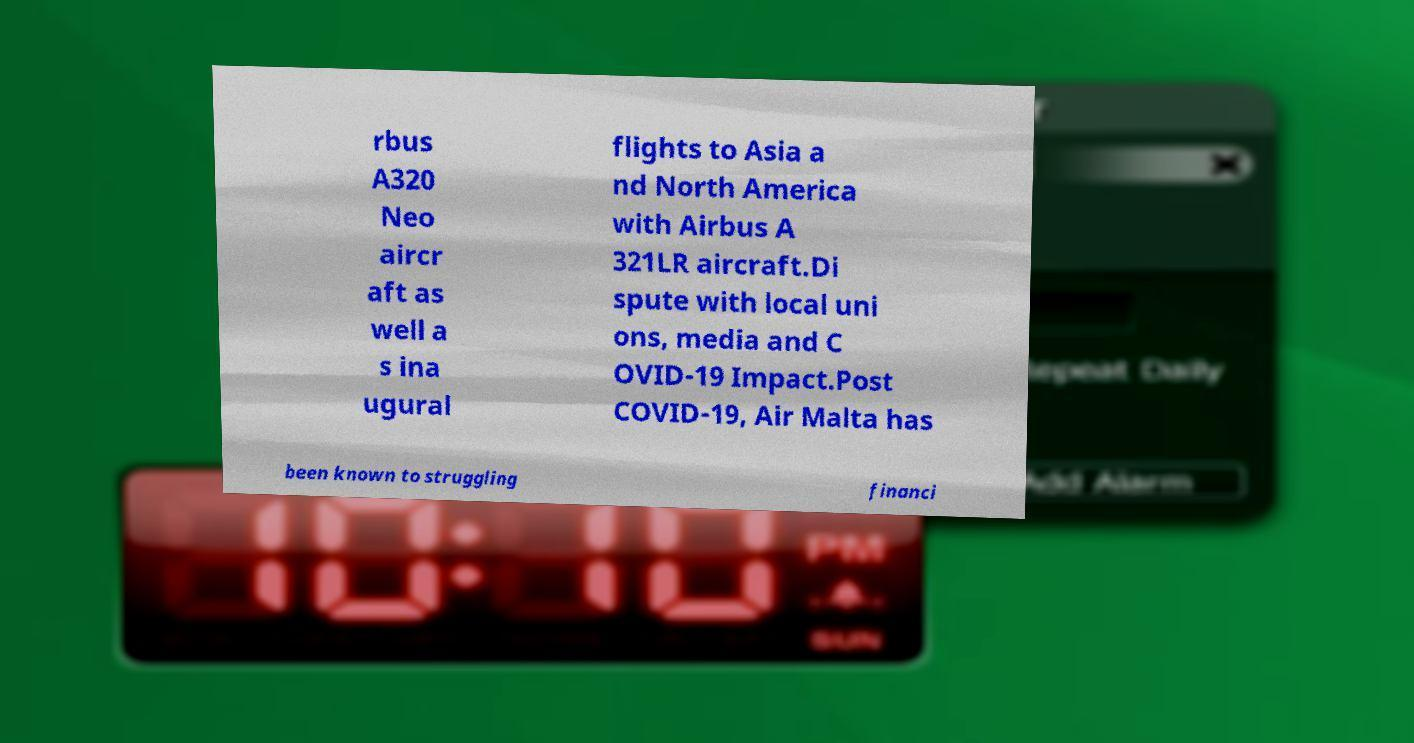Please read and relay the text visible in this image. What does it say? rbus A320 Neo aircr aft as well a s ina ugural flights to Asia a nd North America with Airbus A 321LR aircraft.Di spute with local uni ons, media and C OVID-19 Impact.Post COVID-19, Air Malta has been known to struggling financi 